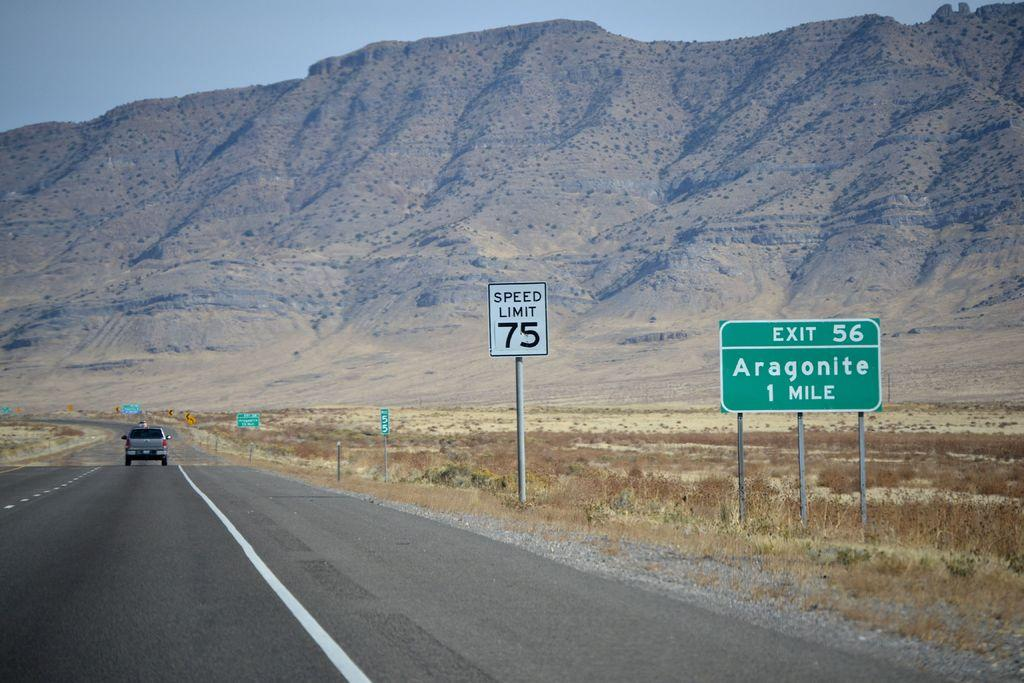<image>
Describe the image concisely. The highway has a speed limit of 75 miles per hour. 